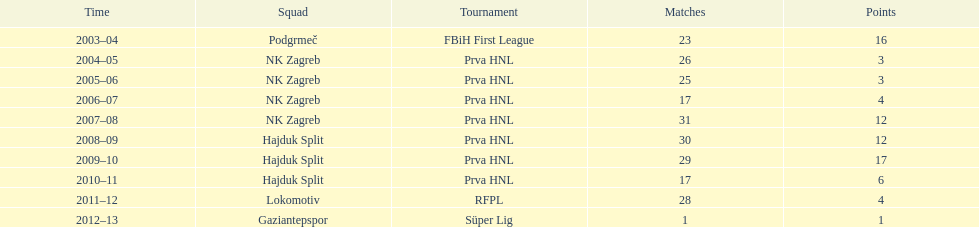At most 26 apps, how many goals were scored in 2004-2005 3. 